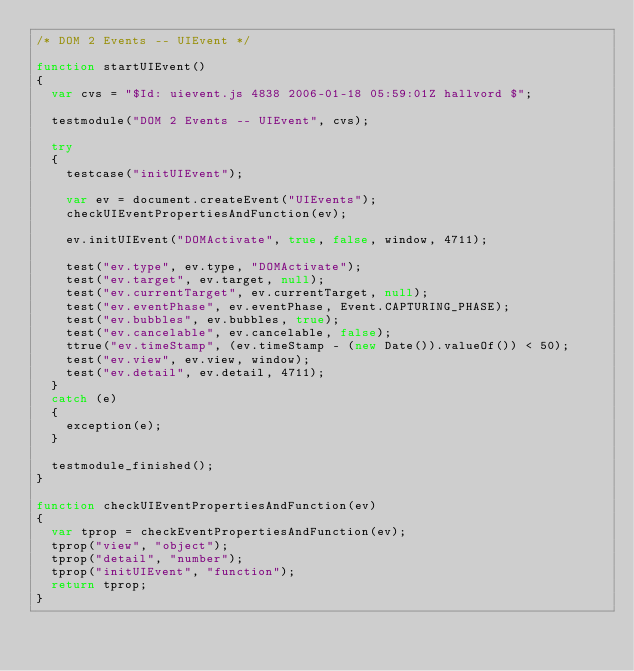<code> <loc_0><loc_0><loc_500><loc_500><_JavaScript_>/* DOM 2 Events -- UIEvent */

function startUIEvent()
{
  var cvs = "$Id: uievent.js 4838 2006-01-18 05:59:01Z hallvord $";

  testmodule("DOM 2 Events -- UIEvent", cvs);

  try
  {
    testcase("initUIEvent");

    var ev = document.createEvent("UIEvents");
    checkUIEventPropertiesAndFunction(ev);

    ev.initUIEvent("DOMActivate", true, false, window, 4711);

    test("ev.type", ev.type, "DOMActivate");
    test("ev.target", ev.target, null);
    test("ev.currentTarget", ev.currentTarget, null);
    test("ev.eventPhase", ev.eventPhase, Event.CAPTURING_PHASE);
    test("ev.bubbles", ev.bubbles, true);
    test("ev.cancelable", ev.cancelable, false);
    ttrue("ev.timeStamp", (ev.timeStamp - (new Date()).valueOf()) < 50);
    test("ev.view", ev.view, window);
    test("ev.detail", ev.detail, 4711);
  }
  catch (e)
  {
    exception(e);
  }

  testmodule_finished();
}

function checkUIEventPropertiesAndFunction(ev)
{
  var tprop = checkEventPropertiesAndFunction(ev);
  tprop("view", "object");
  tprop("detail", "number");
  tprop("initUIEvent", "function");
  return tprop;
}
</code> 